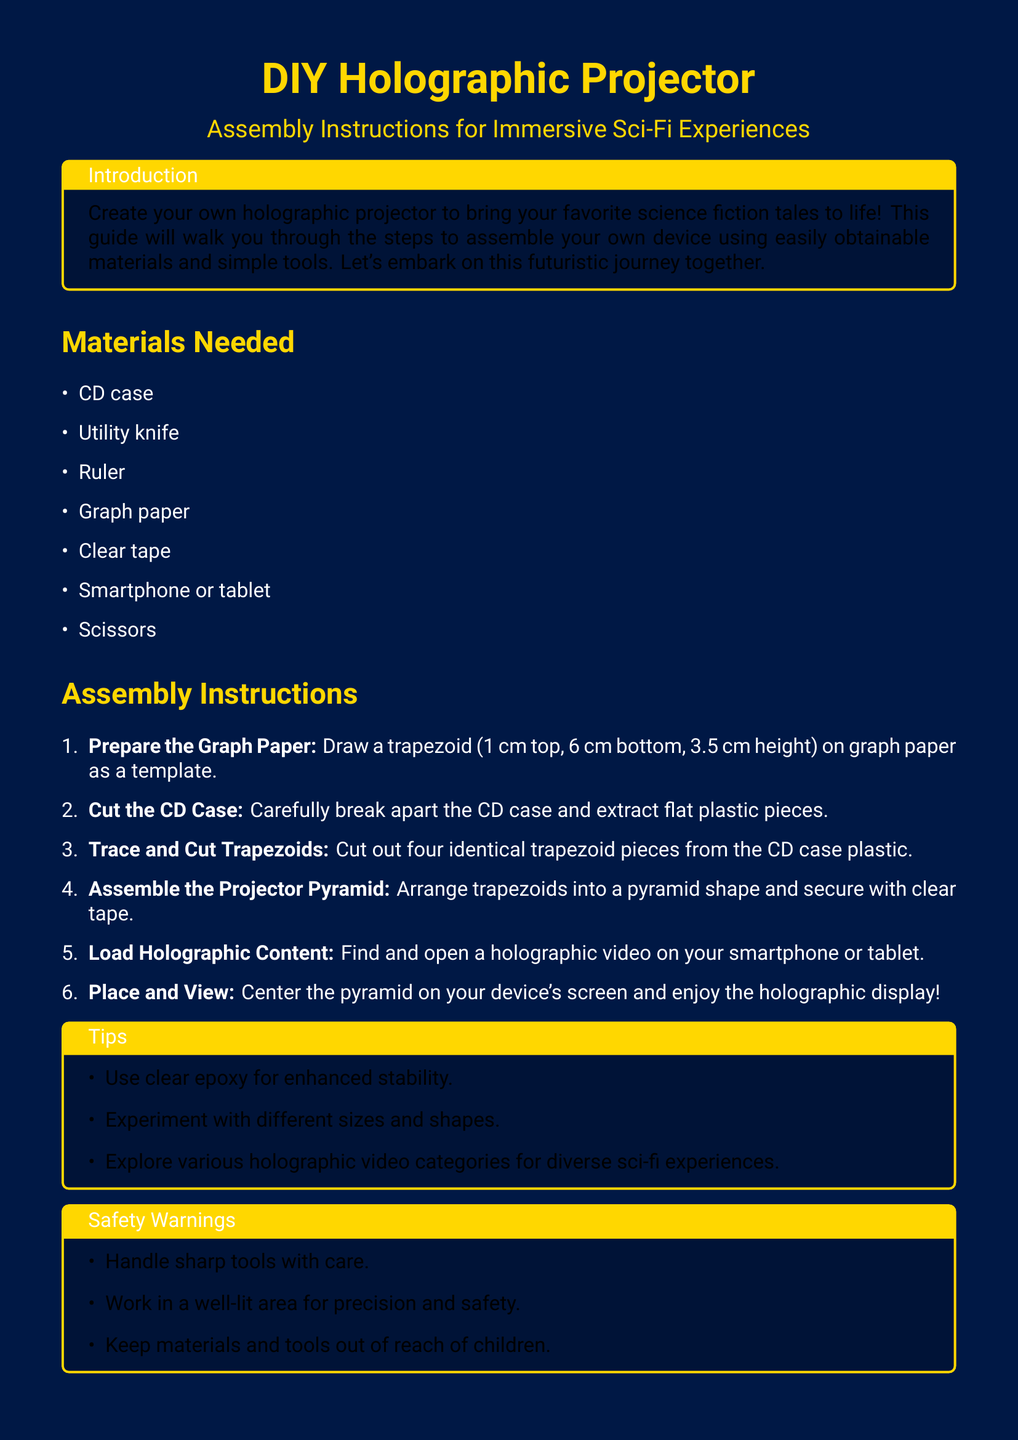What is the height of the trapezoid? The height of the trapezoid drawn on the graph paper is specified in the instructions as 3.5 cm.
Answer: 3.5 cm How many trapezoids should be cut out? The instructions state to cut out four identical trapezoids from the CD case plastic.
Answer: Four What materials are listed for the projector? The list provides several items needed to build the projector. The first item listed is a CD case.
Answer: CD case What is a recommended tool for enhanced stability? The tips section suggests using clear epoxy for enhanced stability during assembly.
Answer: Clear epoxy What should be done with the pyramid before viewing? According to the instructions, the pyramid should be centered on the device's screen before viewing the holographic display.
Answer: Center the pyramid What caution is advised when using tools? The safety warnings section urges to handle sharp tools with care to avoid accidents.
Answer: Handle sharp tools with care What shape is created during assembly? The assembly instructions detail arranging trapezoids into a specific shape, which is a pyramid.
Answer: Pyramid In which area should assembly be performed? The safety warnings advise to work in a well-lit area for precision and safety during the assembly process.
Answer: Well-lit area 